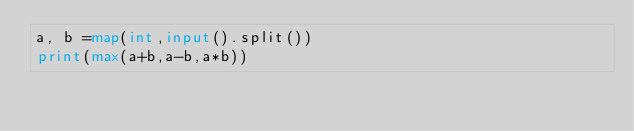<code> <loc_0><loc_0><loc_500><loc_500><_Python_>a, b =map(int,input().split())
print(max(a+b,a-b,a*b))</code> 